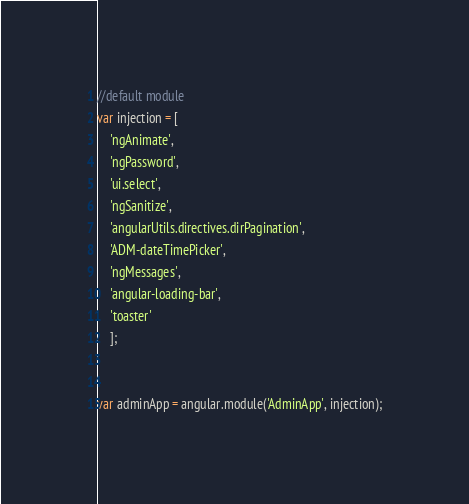<code> <loc_0><loc_0><loc_500><loc_500><_JavaScript_>
//default module
var injection = [
    'ngAnimate',
    'ngPassword',
    'ui.select',
    'ngSanitize',
    'angularUtils.directives.dirPagination',
    'ADM-dateTimePicker',
    'ngMessages',
    'angular-loading-bar',
    'toaster'
    ];


var adminApp = angular.module('AdminApp', injection);



</code> 